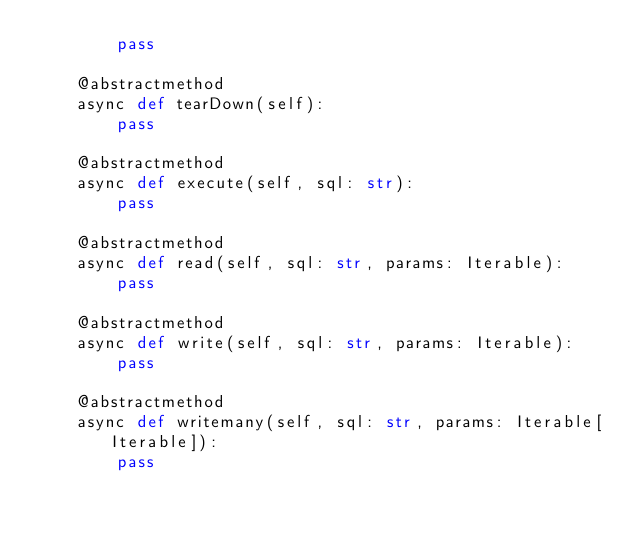<code> <loc_0><loc_0><loc_500><loc_500><_Python_>        pass

    @abstractmethod
    async def tearDown(self):
        pass

    @abstractmethod
    async def execute(self, sql: str):
        pass

    @abstractmethod
    async def read(self, sql: str, params: Iterable):
        pass

    @abstractmethod
    async def write(self, sql: str, params: Iterable):
        pass

    @abstractmethod
    async def writemany(self, sql: str, params: Iterable[Iterable]):
        pass
</code> 